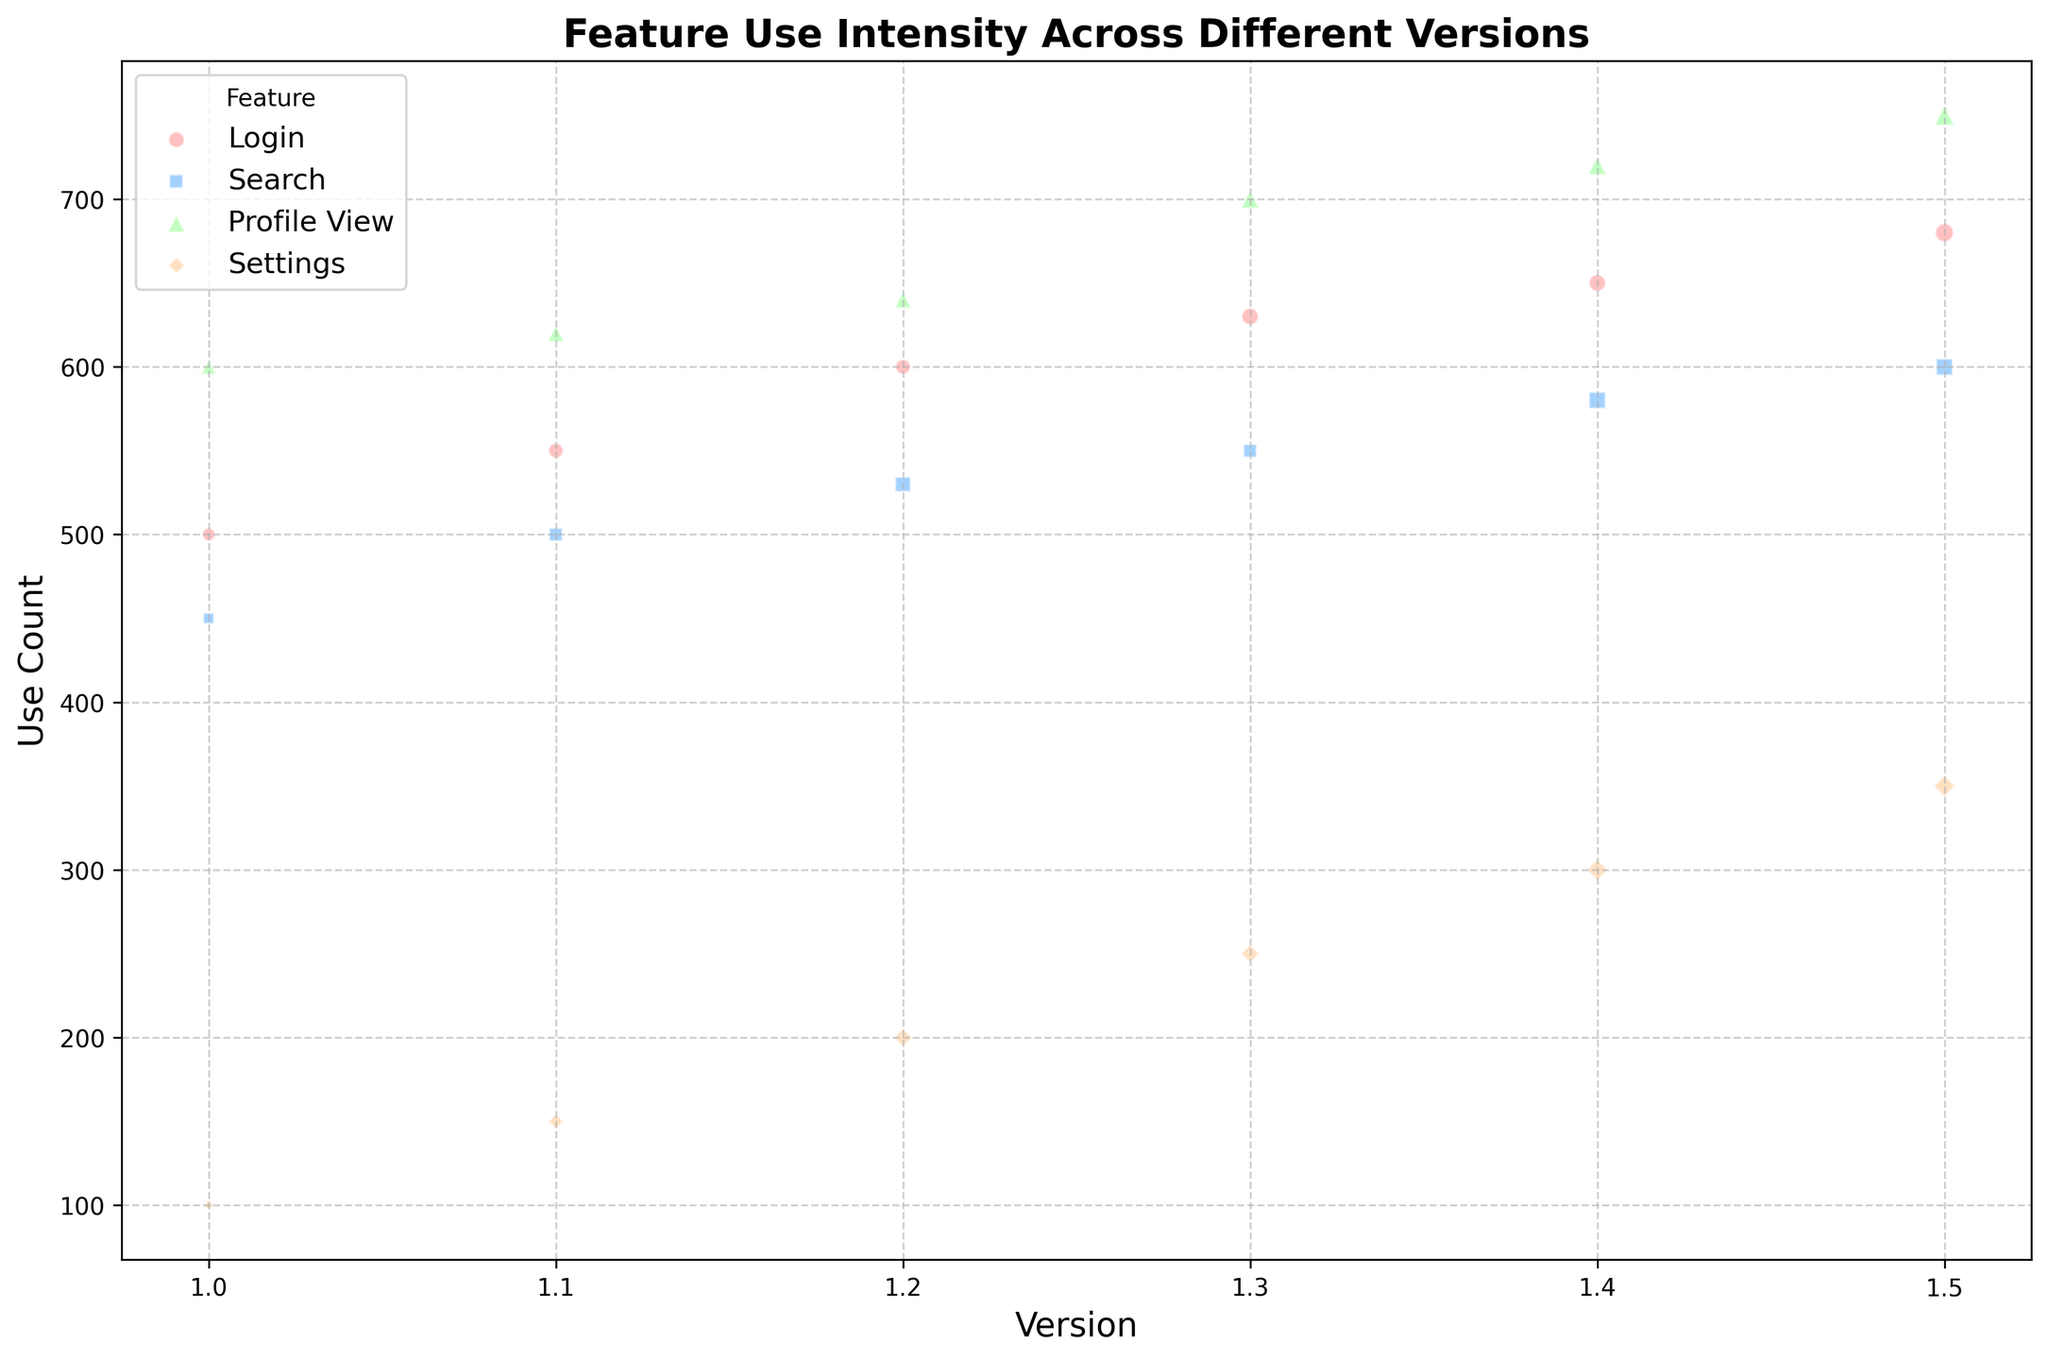What is the feature with the highest use count in version 1.5? Look at the data points for version 1.5 and compare the use counts for each feature. Profile View has the highest use count of 750.
Answer: Profile View Which feature shows a consistent increase in use count across all versions? Check the use count trends across all versions for each feature. All four features show a consistent increase, but Login has a consistently noticeable increase with each version better illustrating the consistent growth.
Answer: Login What is the difference in use count for the Login feature between versions 1.0 and 1.5? Subtract the use count for Login in version 1.0 (500) from the use count in version 1.5 (680). The difference is 680 - 500 = 180.
Answer: 180 Which feature has the smallest bubble size in version 1.0, and what does this indicate? Look at the size of the bubbles in version 1.0. Settings has the smallest bubble size, indicating it has the lowest impact (1) compared to other features in that version.
Answer: Settings Compare the use count for Search and Settings in version 1.4. Which one has a higher use count? Check the use counts for Search (580) and Settings (300) in version 1.4. Search has a higher use count.
Answer: Search For version 1.2, what is the average impact of all features? Add the impact values for all features in version 1.2 (4 + 4 + 5 + 3 = 16) and divide by the number of features (4). The average impact is 16 / 4 = 4.
Answer: 4 In version 1.3, how much does Profile View's use count exceed Search's use count? Subtract the use count for Search (550) from the use count for Profile View (700) in version 1.3. The difference is 700 - 550 = 150.
Answer: 150 Which two features have the same impact in version 1.5, and what is their impact value? Observe the impact values for all features in version 1.5. Both Search and Settings have an impact of 5.
Answer: Search, Settings: 5 How many bubbles are green in the chart, and what feature do they represent? Count the number of green bubbles. There should be one green bubble for each version since Profile View is green.
Answer: 6, Profile View Compare the impact of the Login feature between versions 1.0 and 1.3. How much did it increase? Subtract the impact of Login in version 1.0 (3) from the impact in version 1.3 (5). The increase is 5 - 3 = 2.
Answer: 2 